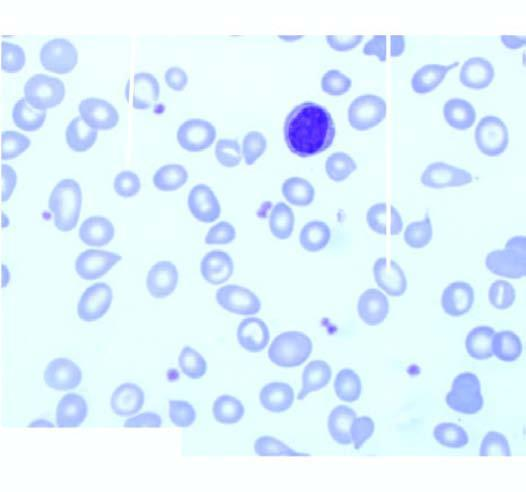what is there?
Answer the question using a single word or phrase. Moderate microcytosis and hypochromia 